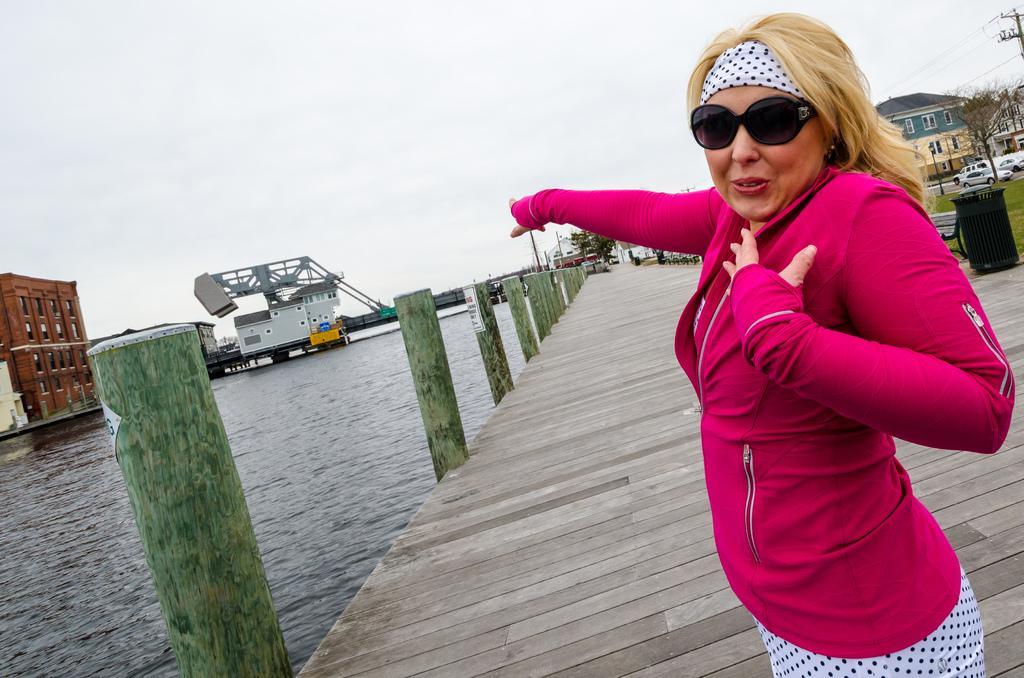How would you summarize this image in a sentence or two? In this image we can see a woman standing and wearing a pink color jacket, there is a ship on the water, there are some buildings, trees, poles and vehicles, in the background we can see the sky. 